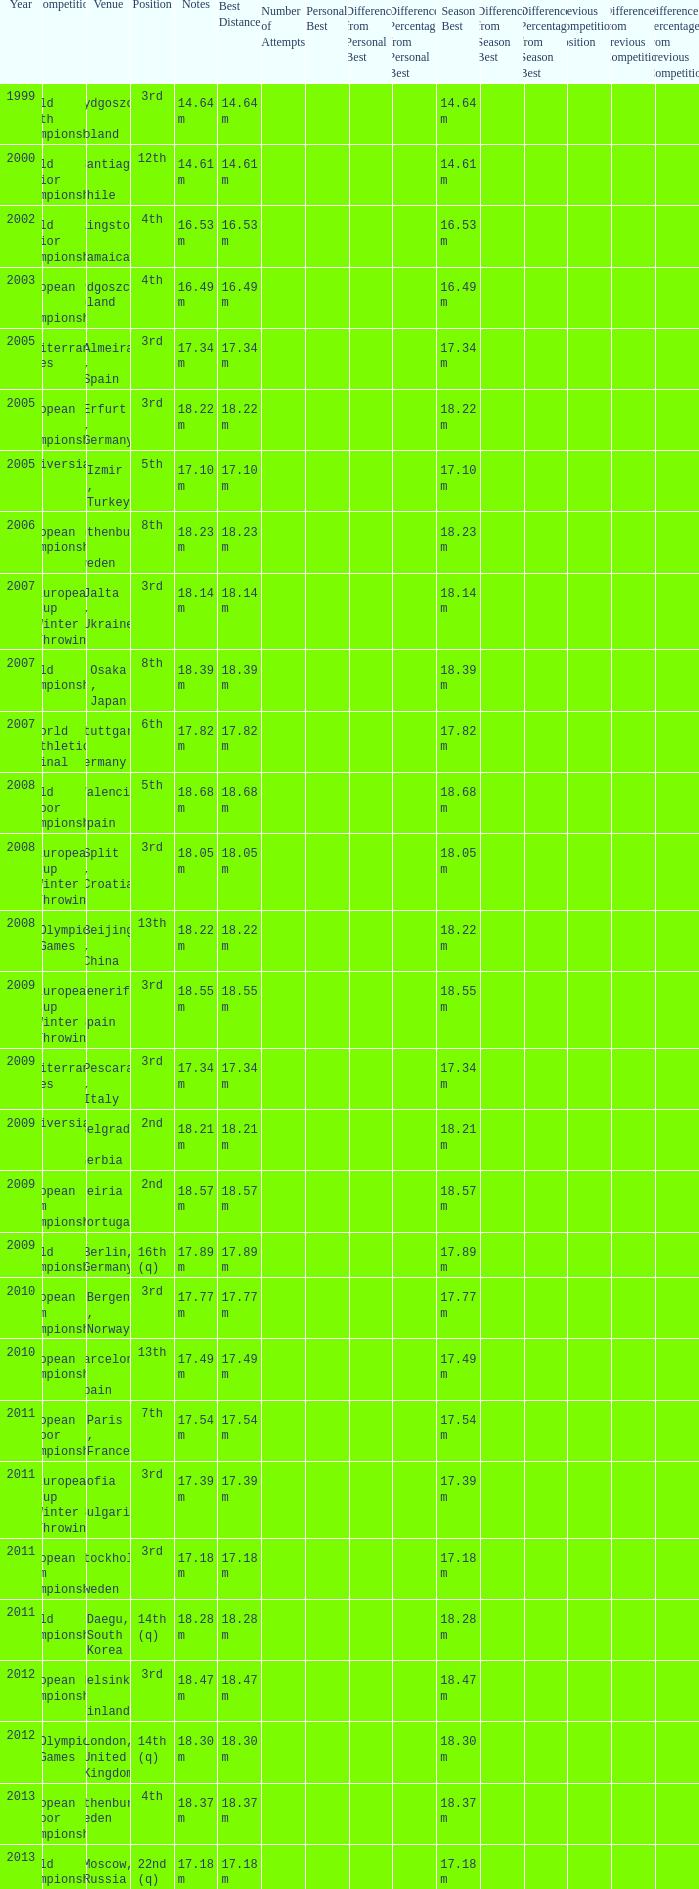Write the full table. {'header': ['Year', 'Competition', 'Venue', 'Position', 'Notes', 'Best Distance', 'Number of Attempts', 'Personal Best', 'Difference from Personal Best', 'Difference Percentage from Personal Best', 'Season Best', 'Difference from Season Best', 'Difference Percentage from Season Best', "Previous Competition's Position", 'Difference from Previous Competition', 'Difference Percentage from Previous Competition '], 'rows': [['1999', 'World Youth Championships', 'Bydgoszcz , Poland', '3rd', '14.64 m', '14.64 m', '', '', '', '', '14.64 m', '', '', '', '', ''], ['2000', 'World Junior Championships', 'Santiago , Chile', '12th', '14.61 m', '14.61 m', '', '', '', '', '14.61 m', '', '', '', '', ''], ['2002', 'World Junior Championships', 'Kingston , Jamaica', '4th', '16.53 m', '16.53 m', '', '', '', '', '16.53 m', '', '', '', '', ''], ['2003', 'European U23 Championships', 'Bydgoszcz, Poland', '4th', '16.49 m', '16.49 m', '', '', '', '', '16.49 m', '', '', '', '', ''], ['2005', 'Mediterranean Games', 'Almeira , Spain', '3rd', '17.34 m', '17.34 m', '', '', '', '', '17.34 m', '', '', '', '', ''], ['2005', 'European U23 Championships', 'Erfurt , Germany', '3rd', '18.22 m', '18.22 m', '', '', '', '', '18.22 m', '', '', '', '', ''], ['2005', 'Universiade', 'Izmir , Turkey', '5th', '17.10 m', '17.10 m', '', '', '', '', '17.10 m', '', '', '', '', ''], ['2006', 'European Championships', 'Gothenburg , Sweden', '8th', '18.23 m', '18.23 m', '', '', '', '', '18.23 m', '', '', '', '', ''], ['2007', 'European Cup Winter Throwing', 'Jalta , Ukraine', '3rd', '18.14 m', '18.14 m', '', '', '', '', '18.14 m', '', '', '', '', ''], ['2007', 'World Championships', 'Osaka , Japan', '8th', '18.39 m', '18.39 m', '', '', '', '', '18.39 m', '', '', '', '', ''], ['2007', 'World Athletics Final', 'Stuttgart , Germany', '6th', '17.82 m', '17.82 m', '', '', '', '', '17.82 m', '', '', '', '', ''], ['2008', 'World Indoor Championships', 'Valencia , Spain', '5th', '18.68 m', '18.68 m', '', '', '', '', '18.68 m', '', '', '', '', ''], ['2008', 'European Cup Winter Throwing', 'Split , Croatia', '3rd', '18.05 m', '18.05 m', '', '', '', '', '18.05 m', '', '', '', '', ''], ['2008', 'Olympic Games', 'Beijing , China', '13th', '18.22 m', '18.22 m', '', '', '', '', '18.22 m', '', '', '', '', ''], ['2009', 'European Cup Winter Throwing', 'Tenerife , Spain', '3rd', '18.55 m', '18.55 m', '', '', '', '', '18.55 m', '', '', '', '', ''], ['2009', 'Mediterranean Games', 'Pescara , Italy', '3rd', '17.34 m', '17.34 m', '', '', '', '', '17.34 m', '', '', '', '', ''], ['2009', 'Universiade', 'Belgrade , Serbia', '2nd', '18.21 m', '18.21 m', '', '', '', '', '18.21 m', '', '', '', '', ''], ['2009', 'European Team Championships', 'Leiria , Portugal', '2nd', '18.57 m', '18.57 m', '', '', '', '', '18.57 m', '', '', '', '', ''], ['2009', 'World Championships', 'Berlin, Germany', '16th (q)', '17.89 m', '17.89 m', '', '', '', '', '17.89 m', '', '', '', '', ''], ['2010', 'European Team Championships', 'Bergen , Norway', '3rd', '17.77 m', '17.77 m', '', '', '', '', '17.77 m', '', '', '', '', ''], ['2010', 'European Championships', 'Barcelona , Spain', '13th', '17.49 m', '17.49 m', '', '', '', '', '17.49 m', '', '', '', '', ''], ['2011', 'European Indoor Championships', 'Paris , France', '7th', '17.54 m', '17.54 m', '', '', '', '', '17.54 m', '', '', '', '', ''], ['2011', 'European Cup Winter Throwing', 'Sofia , Bulgaria', '3rd', '17.39 m', '17.39 m', '', '', '', '', '17.39 m', '', '', '', '', ''], ['2011', 'European Team Championships', 'Stockholm , Sweden', '3rd', '17.18 m', '17.18 m', '', '', '', '', '17.18 m', '', '', '', '', ''], ['2011', 'World Championships', 'Daegu, South Korea', '14th (q)', '18.28 m', '18.28 m', '', '', '', '', '18.28 m', '', '', '', '', ''], ['2012', 'European Championships', 'Helsinki , Finland', '3rd', '18.47 m', '18.47 m', '', '', '', '', '18.47 m', '', '', '', '', ''], ['2012', 'Olympic Games', 'London, United Kingdom', '14th (q)', '18.30 m', '18.30 m', '', '', '', '', '18.30 m', '', '', '', '', ''], ['2013', 'European Indoor Championships', 'Gothenburg, Sweden', '4th', '18.37 m', '18.37 m', '', '', '', '', '18.37 m', '', '', '', '', ''], ['2013', 'World Championships', 'Moscow, Russia', '22nd (q)', '17.18 m', '17.18 m', '', '', '', '', '17.18 m', '', '', '', '', '']]} What position is 1999? 3rd. 